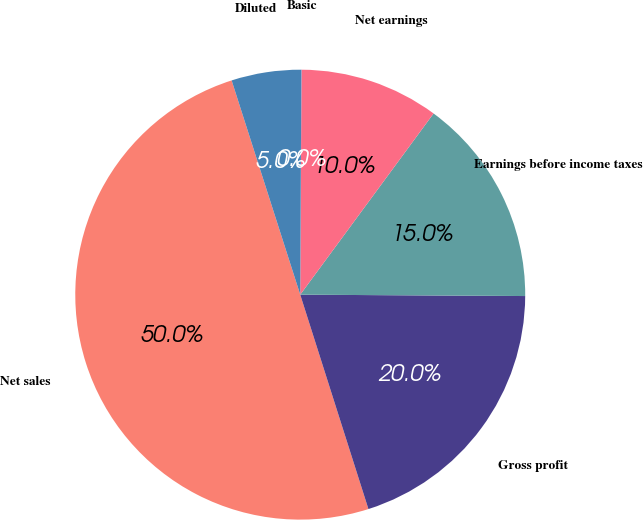<chart> <loc_0><loc_0><loc_500><loc_500><pie_chart><fcel>Net sales<fcel>Gross profit<fcel>Earnings before income taxes<fcel>Net earnings<fcel>Basic<fcel>Diluted<nl><fcel>49.97%<fcel>20.0%<fcel>15.0%<fcel>10.01%<fcel>0.01%<fcel>5.01%<nl></chart> 